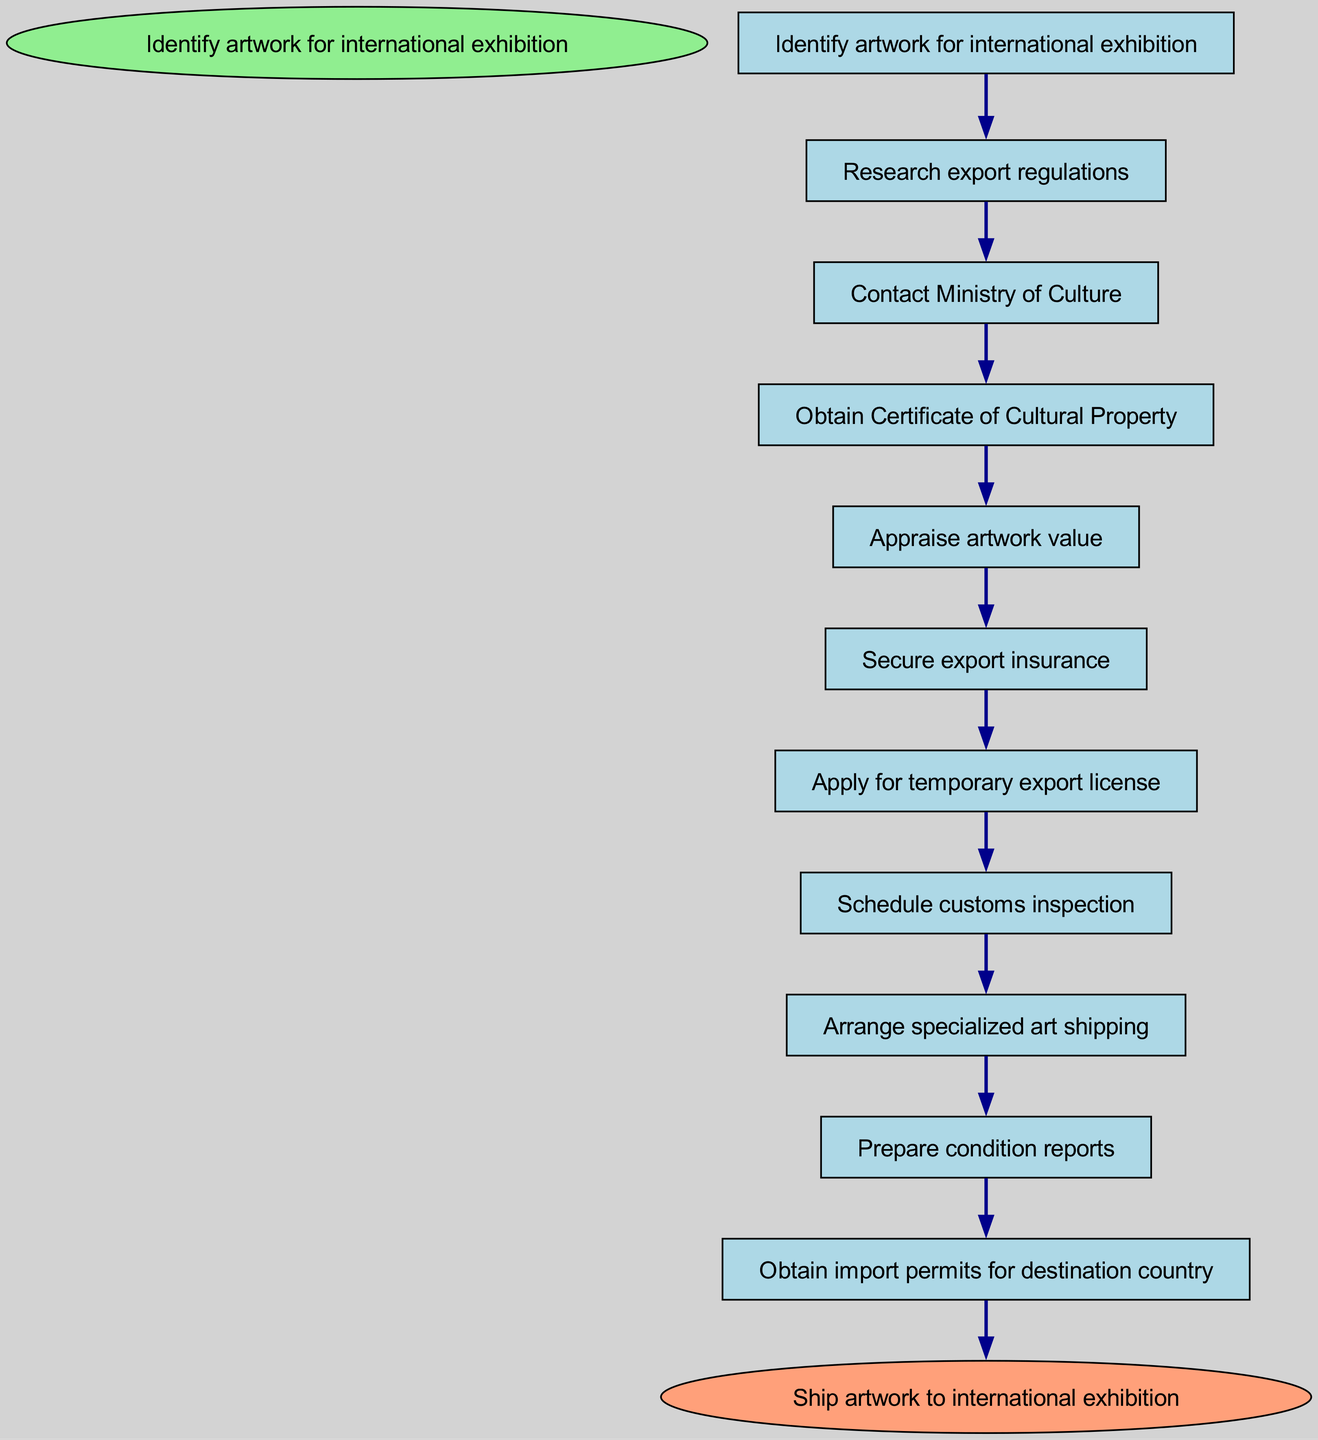What is the starting point of the pathway? The diagram indicates that the starting point is labeled "Identify artwork for international exhibition." This is the first node in the pathway and serves as the entry point for the entire process.
Answer: Identify artwork for international exhibition How many nodes are there in the pathway? By counting each listed node in the diagram, including the starting and ending points, we find there are a total of 11 nodes.
Answer: 11 What is the last action before shipping the artwork? The last action before shipping is "Obtain import permits for destination country." This is positioned as the final node before reaching the end of the pathway labeled "Ship artwork to international exhibition."
Answer: Obtain import permits for destination country Which node follows "Secure export insurance"? The next node after "Secure export insurance" is "Apply for temporary export license." This flow continues the pathway as indicated by the directed edge connecting these two nodes.
Answer: Apply for temporary export license What is the relationship between "Obtain Certificate of Cultural Property" and "Appraise artwork value"? The relationship is sequential, where "Obtain Certificate of Cultural Property" leads directly to "Appraise artwork value." This indicates that obtaining the certificate is a prerequisite step before appraising value.
Answer: Sequential relationship What is the edge count between "Schedule customs inspection" and any subsequent node? There is a single edge leading from "Schedule customs inspection" to "Arrange specialized art shipping," indicating the next step in the pathway following the customs inspection.
Answer: 1 Is "Research export regulations" a terminal node? "Research export regulations" is not a terminal node; it is an intermediate node that connects to "Contact Ministry of Culture," showing that further actions are required before completion.
Answer: No How many steps are needed to go from "Identify artwork for international exhibition" to "Obtain import permits for destination country"? The pathway includes 10 steps or transitions starting from "Identify artwork for international exhibition" and finally leading to "Obtain import permits for destination country." The flow is continuous throughout the nodes.
Answer: 10 What must be arranged after "Arrange specialized art shipping"? Following "Arrange specialized art shipping," the next required action is to "Prepare condition reports." This indicates that condition reports are essential prior to shipping.
Answer: Prepare condition reports 